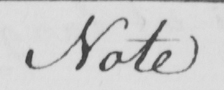Please provide the text content of this handwritten line. Note 